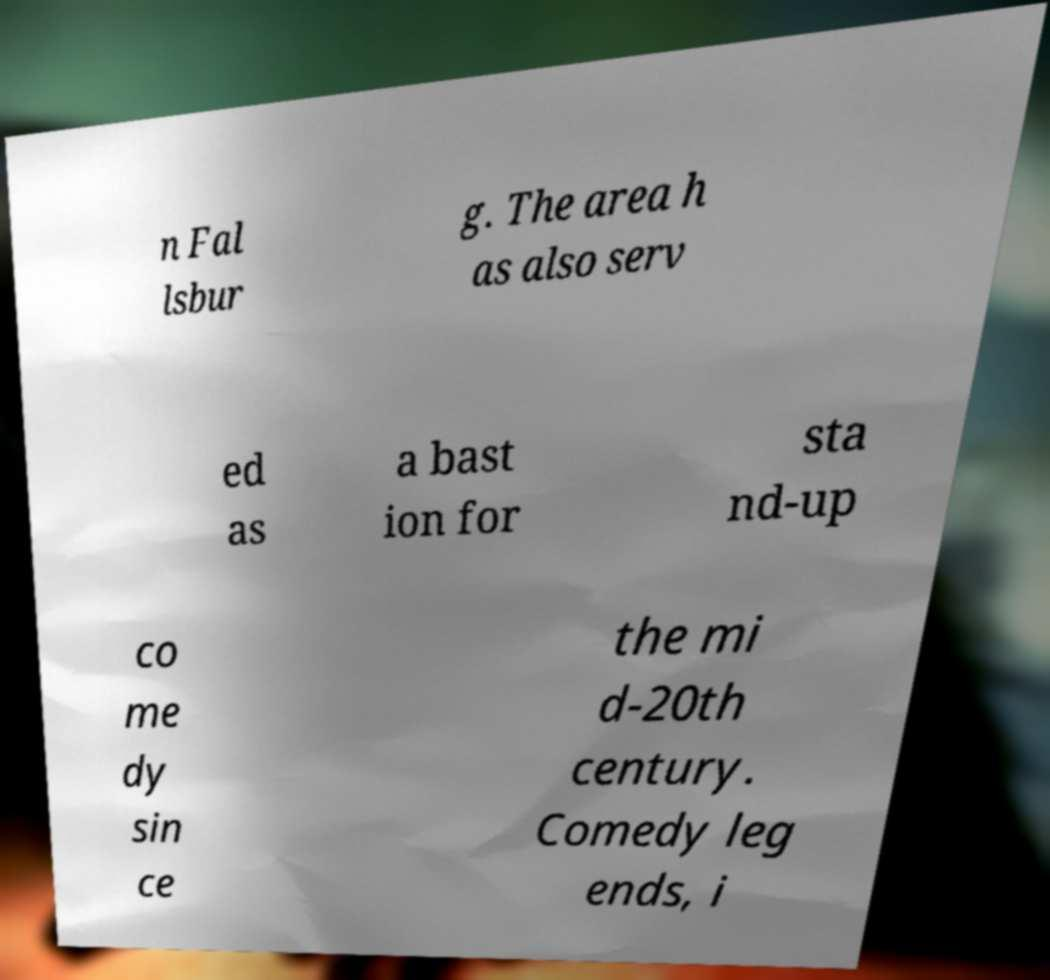Could you assist in decoding the text presented in this image and type it out clearly? n Fal lsbur g. The area h as also serv ed as a bast ion for sta nd-up co me dy sin ce the mi d-20th century. Comedy leg ends, i 